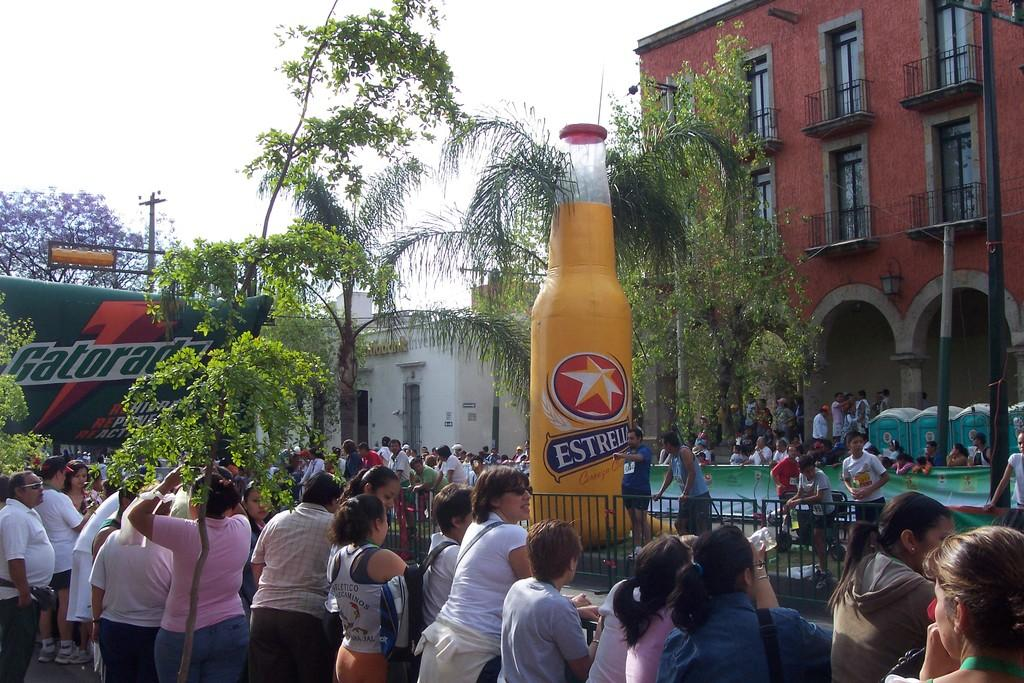Provide a one-sentence caption for the provided image. People are gathered outdoors at an event that includes a large Gatorade banner and a blow up beer bottle. 